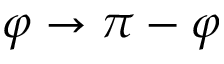<formula> <loc_0><loc_0><loc_500><loc_500>\varphi \rightarrow \pi - \varphi</formula> 